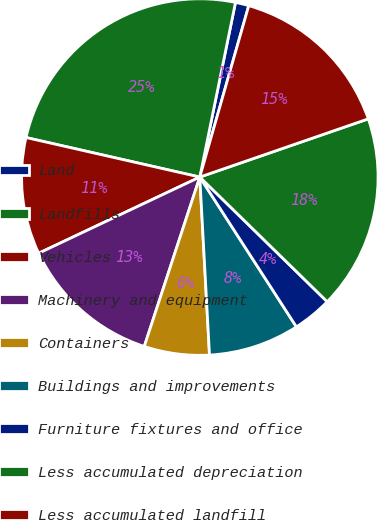<chart> <loc_0><loc_0><loc_500><loc_500><pie_chart><fcel>Land<fcel>Landfills<fcel>Vehicles<fcel>Machinery and equipment<fcel>Containers<fcel>Buildings and improvements<fcel>Furniture fixtures and office<fcel>Less accumulated depreciation<fcel>Less accumulated landfill<nl><fcel>1.22%<fcel>24.65%<fcel>10.59%<fcel>12.93%<fcel>5.91%<fcel>8.25%<fcel>3.56%<fcel>17.62%<fcel>15.28%<nl></chart> 